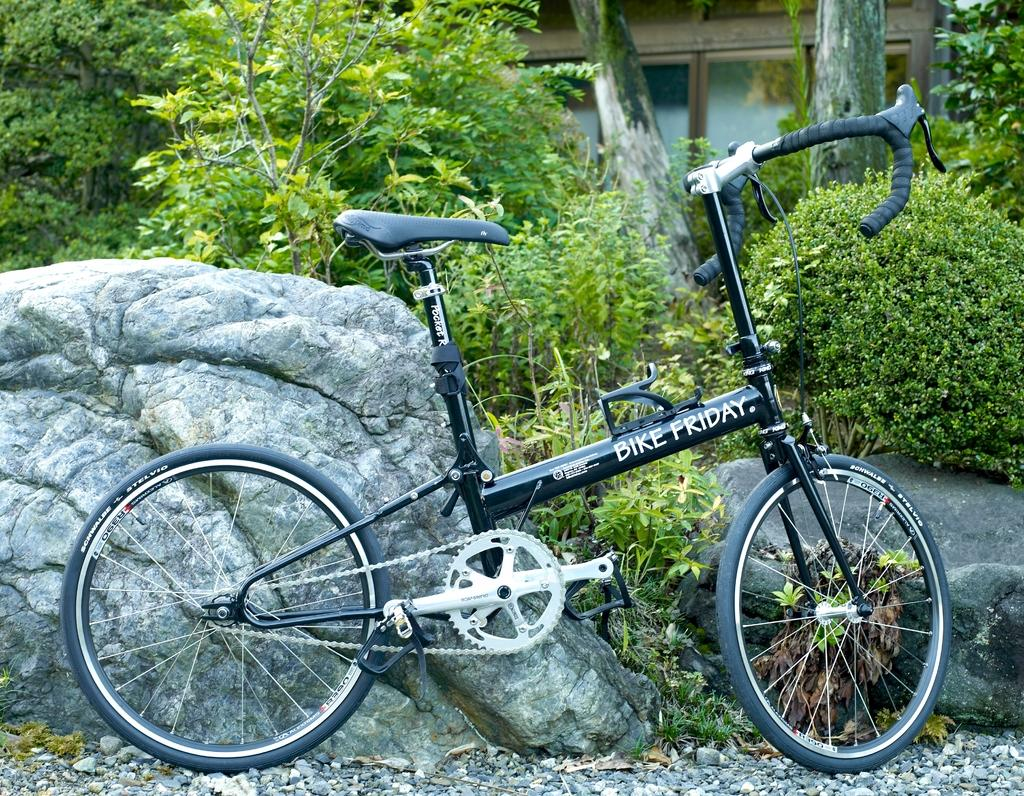What type of surface is covered by the stones in the image? The stones are on the floor in the image. What is the main feature of the image? It appears to be a rock in the image. What can be seen in the foreground of the image? There is a bicycle in the foreground of the image. What type of vegetation is visible in the image? There is greenery visible in the image. What structure can be seen in the background of the image? There is a house in the background of the image. How many boys are blowing up the stocking in the image? There are no boys or stockings present in the image. 